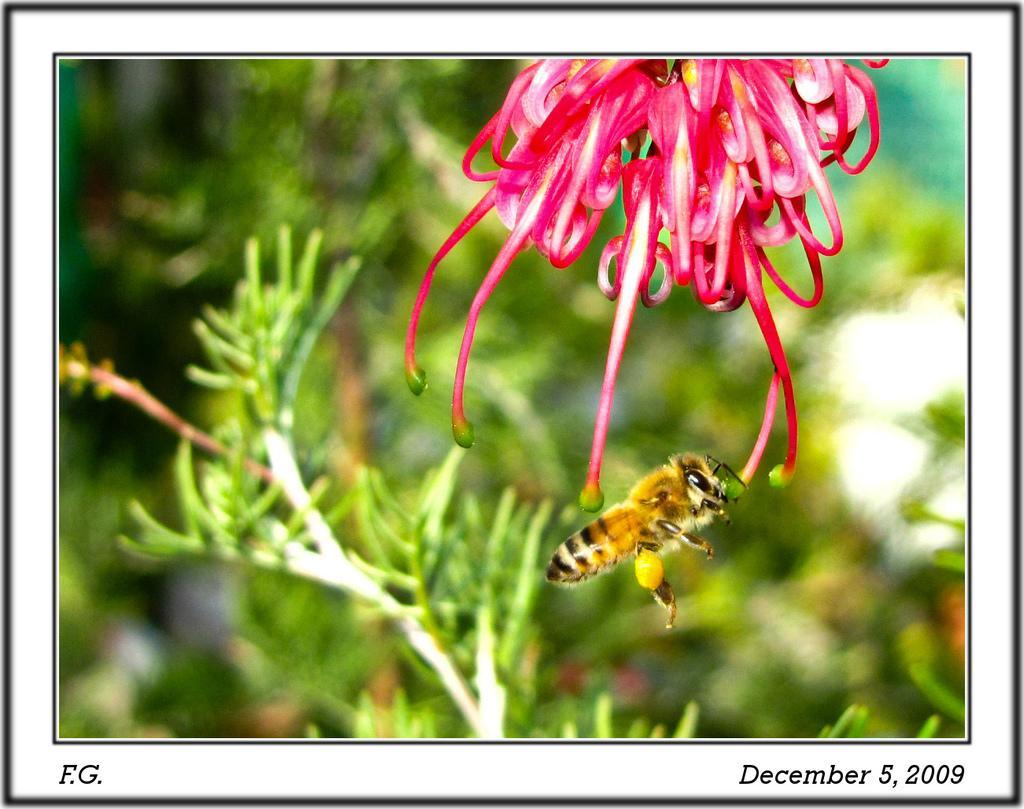Describe this image in one or two sentences. This image consists of a plant. There is a flower at the top. It is in pink color. There is a honey bee in the middle. 